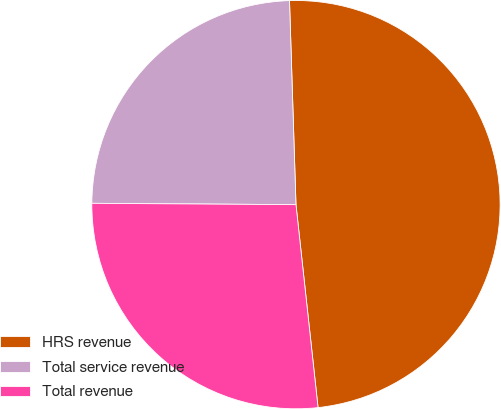Convert chart to OTSL. <chart><loc_0><loc_0><loc_500><loc_500><pie_chart><fcel>HRS revenue<fcel>Total service revenue<fcel>Total revenue<nl><fcel>48.78%<fcel>24.39%<fcel>26.83%<nl></chart> 